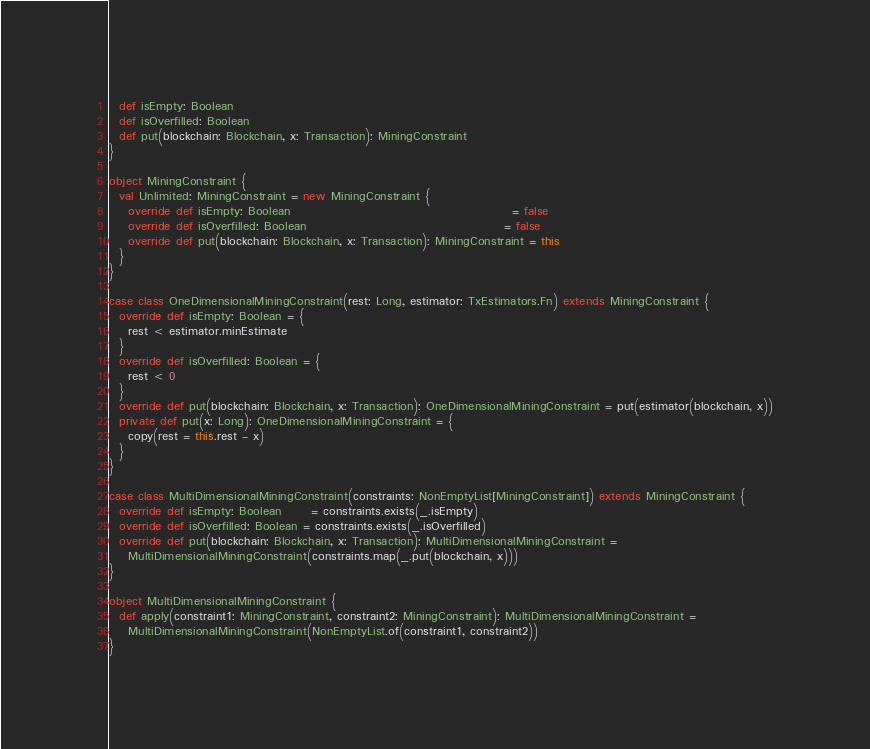Convert code to text. <code><loc_0><loc_0><loc_500><loc_500><_Scala_>  def isEmpty: Boolean
  def isOverfilled: Boolean
  def put(blockchain: Blockchain, x: Transaction): MiningConstraint
}

object MiningConstraint {
  val Unlimited: MiningConstraint = new MiningConstraint {
    override def isEmpty: Boolean                                              = false
    override def isOverfilled: Boolean                                         = false
    override def put(blockchain: Blockchain, x: Transaction): MiningConstraint = this
  }
}

case class OneDimensionalMiningConstraint(rest: Long, estimator: TxEstimators.Fn) extends MiningConstraint {
  override def isEmpty: Boolean = {
    rest < estimator.minEstimate
  }
  override def isOverfilled: Boolean = {
    rest < 0
  }
  override def put(blockchain: Blockchain, x: Transaction): OneDimensionalMiningConstraint = put(estimator(blockchain, x))
  private def put(x: Long): OneDimensionalMiningConstraint = {
    copy(rest = this.rest - x)
  }
}

case class MultiDimensionalMiningConstraint(constraints: NonEmptyList[MiningConstraint]) extends MiningConstraint {
  override def isEmpty: Boolean      = constraints.exists(_.isEmpty)
  override def isOverfilled: Boolean = constraints.exists(_.isOverfilled)
  override def put(blockchain: Blockchain, x: Transaction): MultiDimensionalMiningConstraint =
    MultiDimensionalMiningConstraint(constraints.map(_.put(blockchain, x)))
}

object MultiDimensionalMiningConstraint {
  def apply(constraint1: MiningConstraint, constraint2: MiningConstraint): MultiDimensionalMiningConstraint =
    MultiDimensionalMiningConstraint(NonEmptyList.of(constraint1, constraint2))
}
</code> 